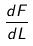Convert formula to latex. <formula><loc_0><loc_0><loc_500><loc_500>\frac { d F } { d L }</formula> 